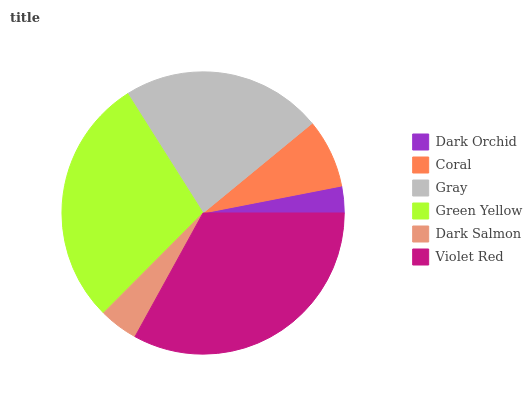Is Dark Orchid the minimum?
Answer yes or no. Yes. Is Violet Red the maximum?
Answer yes or no. Yes. Is Coral the minimum?
Answer yes or no. No. Is Coral the maximum?
Answer yes or no. No. Is Coral greater than Dark Orchid?
Answer yes or no. Yes. Is Dark Orchid less than Coral?
Answer yes or no. Yes. Is Dark Orchid greater than Coral?
Answer yes or no. No. Is Coral less than Dark Orchid?
Answer yes or no. No. Is Gray the high median?
Answer yes or no. Yes. Is Coral the low median?
Answer yes or no. Yes. Is Dark Salmon the high median?
Answer yes or no. No. Is Dark Salmon the low median?
Answer yes or no. No. 